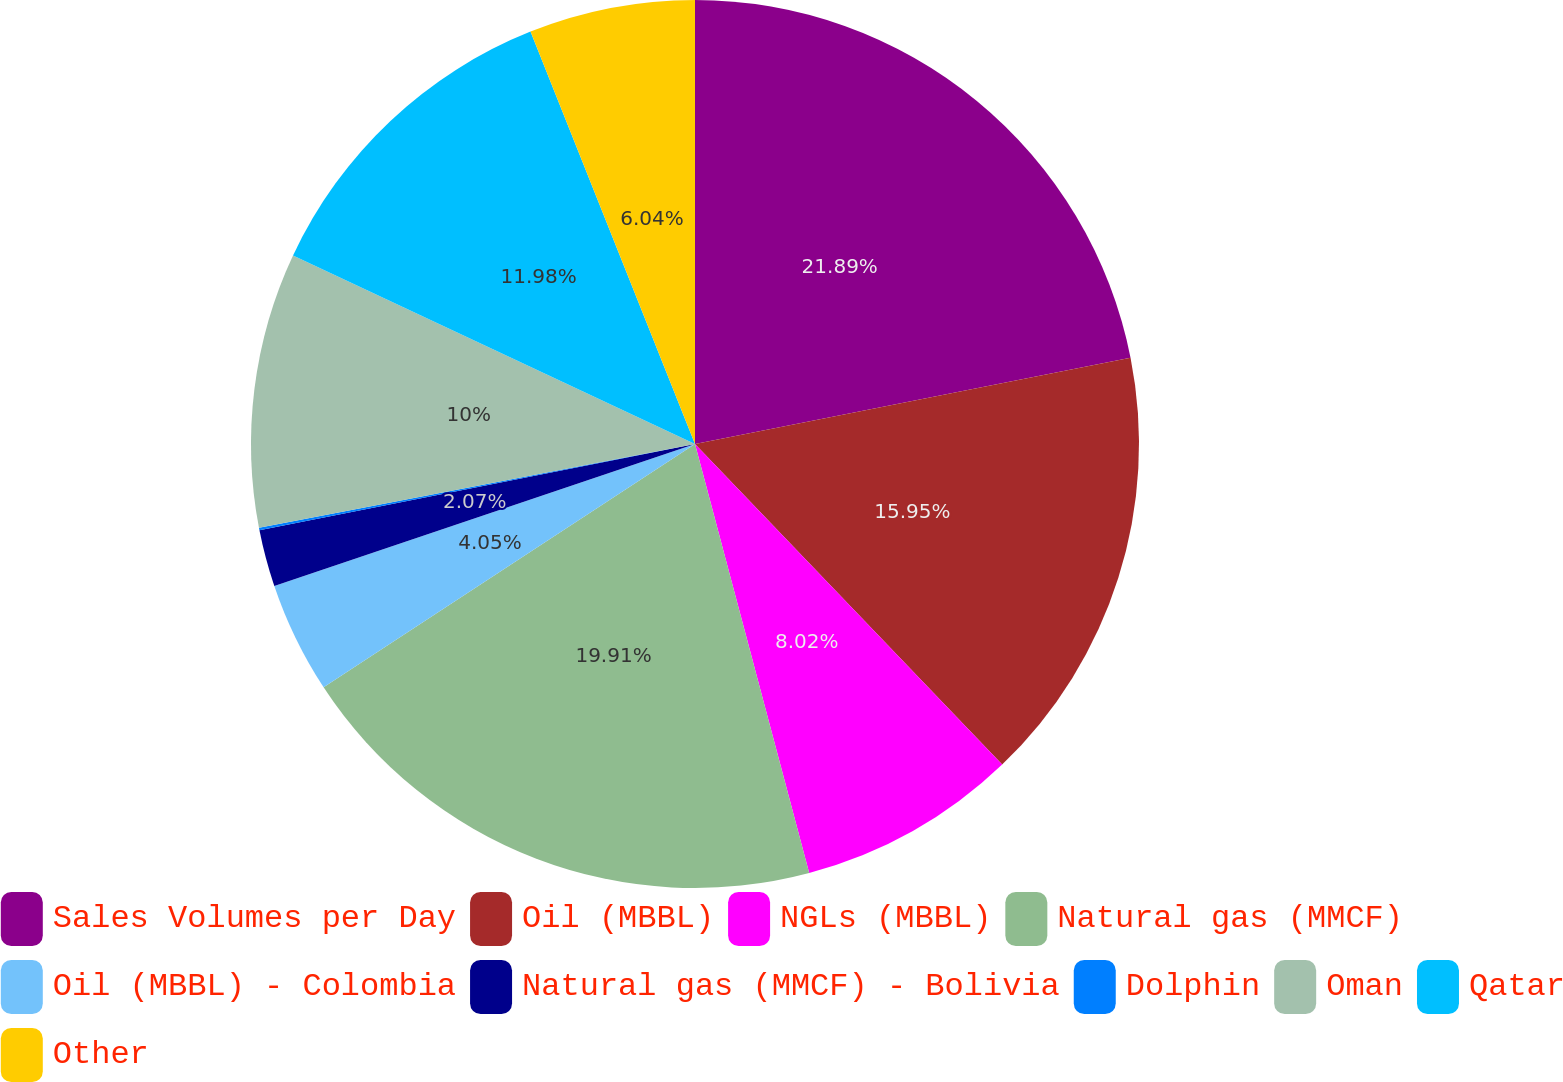Convert chart. <chart><loc_0><loc_0><loc_500><loc_500><pie_chart><fcel>Sales Volumes per Day<fcel>Oil (MBBL)<fcel>NGLs (MBBL)<fcel>Natural gas (MMCF)<fcel>Oil (MBBL) - Colombia<fcel>Natural gas (MMCF) - Bolivia<fcel>Dolphin<fcel>Oman<fcel>Qatar<fcel>Other<nl><fcel>21.89%<fcel>15.95%<fcel>8.02%<fcel>19.91%<fcel>4.05%<fcel>2.07%<fcel>0.09%<fcel>10.0%<fcel>11.98%<fcel>6.04%<nl></chart> 